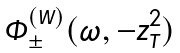Convert formula to latex. <formula><loc_0><loc_0><loc_500><loc_500>\Phi _ { \pm } ^ { ( W ) } ( \omega , - \boldmath z _ { T } ^ { 2 } )</formula> 